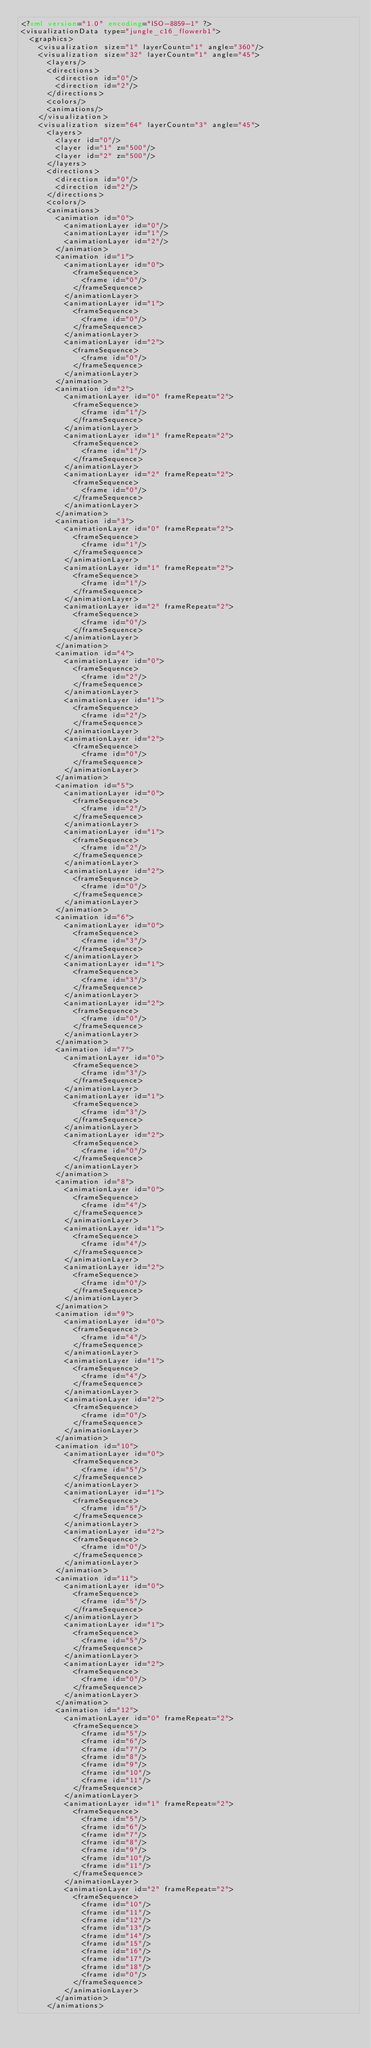<code> <loc_0><loc_0><loc_500><loc_500><_XML_><?xml version="1.0" encoding="ISO-8859-1" ?><visualizationData type="jungle_c16_flowerb1">
  <graphics>
    <visualization size="1" layerCount="1" angle="360"/>
    <visualization size="32" layerCount="1" angle="45">
      <layers/>
      <directions>
        <direction id="0"/>
        <direction id="2"/>
      </directions>
      <colors/>
      <animations/>
    </visualization>
    <visualization size="64" layerCount="3" angle="45">
      <layers>
        <layer id="0"/>
        <layer id="1" z="500"/>
        <layer id="2" z="500"/>
      </layers>
      <directions>
        <direction id="0"/>
        <direction id="2"/>
      </directions>
      <colors/>
      <animations>
        <animation id="0">
          <animationLayer id="0"/>
          <animationLayer id="1"/>
          <animationLayer id="2"/>
        </animation>
        <animation id="1">
          <animationLayer id="0">
            <frameSequence>
              <frame id="0"/>
            </frameSequence>
          </animationLayer>
          <animationLayer id="1">
            <frameSequence>
              <frame id="0"/>
            </frameSequence>
          </animationLayer>
          <animationLayer id="2">
            <frameSequence>
              <frame id="0"/>
            </frameSequence>
          </animationLayer>
        </animation>
        <animation id="2">
          <animationLayer id="0" frameRepeat="2">
            <frameSequence>
              <frame id="1"/>
            </frameSequence>
          </animationLayer>
          <animationLayer id="1" frameRepeat="2">
            <frameSequence>
              <frame id="1"/>
            </frameSequence>
          </animationLayer>
          <animationLayer id="2" frameRepeat="2">
            <frameSequence>
              <frame id="0"/>
            </frameSequence>
          </animationLayer>
        </animation>
        <animation id="3">
          <animationLayer id="0" frameRepeat="2">
            <frameSequence>
              <frame id="1"/>
            </frameSequence>
          </animationLayer>
          <animationLayer id="1" frameRepeat="2">
            <frameSequence>
              <frame id="1"/>
            </frameSequence>
          </animationLayer>
          <animationLayer id="2" frameRepeat="2">
            <frameSequence>
              <frame id="0"/>
            </frameSequence>
          </animationLayer>
        </animation>
        <animation id="4">
          <animationLayer id="0">
            <frameSequence>
              <frame id="2"/>
            </frameSequence>
          </animationLayer>
          <animationLayer id="1">
            <frameSequence>
              <frame id="2"/>
            </frameSequence>
          </animationLayer>
          <animationLayer id="2">
            <frameSequence>
              <frame id="0"/>
            </frameSequence>
          </animationLayer>
        </animation>
        <animation id="5">
          <animationLayer id="0">
            <frameSequence>
              <frame id="2"/>
            </frameSequence>
          </animationLayer>
          <animationLayer id="1">
            <frameSequence>
              <frame id="2"/>
            </frameSequence>
          </animationLayer>
          <animationLayer id="2">
            <frameSequence>
              <frame id="0"/>
            </frameSequence>
          </animationLayer>
        </animation>
        <animation id="6">
          <animationLayer id="0">
            <frameSequence>
              <frame id="3"/>
            </frameSequence>
          </animationLayer>
          <animationLayer id="1">
            <frameSequence>
              <frame id="3"/>
            </frameSequence>
          </animationLayer>
          <animationLayer id="2">
            <frameSequence>
              <frame id="0"/>
            </frameSequence>
          </animationLayer>
        </animation>
        <animation id="7">
          <animationLayer id="0">
            <frameSequence>
              <frame id="3"/>
            </frameSequence>
          </animationLayer>
          <animationLayer id="1">
            <frameSequence>
              <frame id="3"/>
            </frameSequence>
          </animationLayer>
          <animationLayer id="2">
            <frameSequence>
              <frame id="0"/>
            </frameSequence>
          </animationLayer>
        </animation>
        <animation id="8">
          <animationLayer id="0">
            <frameSequence>
              <frame id="4"/>
            </frameSequence>
          </animationLayer>
          <animationLayer id="1">
            <frameSequence>
              <frame id="4"/>
            </frameSequence>
          </animationLayer>
          <animationLayer id="2">
            <frameSequence>
              <frame id="0"/>
            </frameSequence>
          </animationLayer>
        </animation>
        <animation id="9">
          <animationLayer id="0">
            <frameSequence>
              <frame id="4"/>
            </frameSequence>
          </animationLayer>
          <animationLayer id="1">
            <frameSequence>
              <frame id="4"/>
            </frameSequence>
          </animationLayer>
          <animationLayer id="2">
            <frameSequence>
              <frame id="0"/>
            </frameSequence>
          </animationLayer>
        </animation>
        <animation id="10">
          <animationLayer id="0">
            <frameSequence>
              <frame id="5"/>
            </frameSequence>
          </animationLayer>
          <animationLayer id="1">
            <frameSequence>
              <frame id="5"/>
            </frameSequence>
          </animationLayer>
          <animationLayer id="2">
            <frameSequence>
              <frame id="0"/>
            </frameSequence>
          </animationLayer>
        </animation>
        <animation id="11">
          <animationLayer id="0">
            <frameSequence>
              <frame id="5"/>
            </frameSequence>
          </animationLayer>
          <animationLayer id="1">
            <frameSequence>
              <frame id="5"/>
            </frameSequence>
          </animationLayer>
          <animationLayer id="2">
            <frameSequence>
              <frame id="0"/>
            </frameSequence>
          </animationLayer>
        </animation>
        <animation id="12">
          <animationLayer id="0" frameRepeat="2">
            <frameSequence>
              <frame id="5"/>
              <frame id="6"/>
              <frame id="7"/>
              <frame id="8"/>
              <frame id="9"/>
              <frame id="10"/>
              <frame id="11"/>
            </frameSequence>
          </animationLayer>
          <animationLayer id="1" frameRepeat="2">
            <frameSequence>
              <frame id="5"/>
              <frame id="6"/>
              <frame id="7"/>
              <frame id="8"/>
              <frame id="9"/>
              <frame id="10"/>
              <frame id="11"/>
            </frameSequence>
          </animationLayer>
          <animationLayer id="2" frameRepeat="2">
            <frameSequence>
              <frame id="10"/>
              <frame id="11"/>
              <frame id="12"/>
              <frame id="13"/>
              <frame id="14"/>
              <frame id="15"/>
              <frame id="16"/>
              <frame id="17"/>
              <frame id="18"/>
              <frame id="0"/>
            </frameSequence>
          </animationLayer>
        </animation>
      </animations></code> 